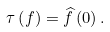<formula> <loc_0><loc_0><loc_500><loc_500>\tau \left ( f \right ) = \widehat { f } \left ( 0 \right ) .</formula> 